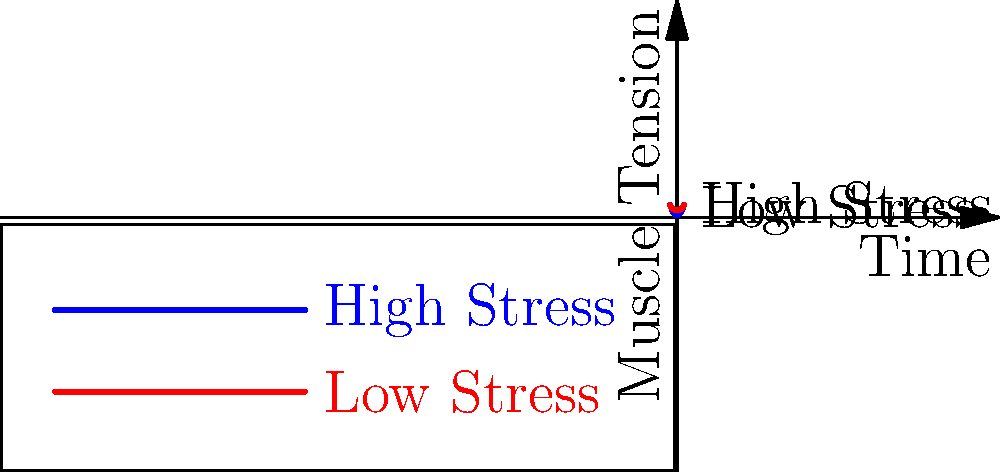As a business owner who recently faced financial challenges, you understand the importance of managing stress. Consider the graph showing muscle tension over time for high and low stress scenarios. If the area under each curve represents the total energy expended by the muscles, calculate the percentage increase in energy expenditure for the high stress scenario compared to the low stress scenario over the time interval $[-3, 3]$. To solve this problem, we'll follow these steps:

1. Calculate the area under the high stress curve:
   $A_h = \int_{-3}^{3} (0.5x^2 + 1) dx$
   $= [0.5 \cdot \frac{x^3}{3} + x]_{-3}^{3}$
   $= (4.5 + 3) - (-4.5 - 3) = 15$

2. Calculate the area under the low stress curve:
   $A_l = \int_{-3}^{3} (0.25x^2 + 3) dx$
   $= [0.25 \cdot \frac{x^3}{3} + 3x]_{-3}^{3}$
   $= (2.25 + 9) - (-2.25 - 9) = 22.5$

3. Calculate the difference in energy expenditure:
   $\Delta E = A_h - A_l = 15 - 22.5 = -7.5$

4. Calculate the percentage increase:
   $\text{Percentage Increase} = \frac{\Delta E}{A_l} \times 100\%$
   $= \frac{-7.5}{22.5} \times 100\% = -33.33\%$

The negative percentage indicates a decrease in energy expenditure for the high stress scenario.
Answer: -33.33% 